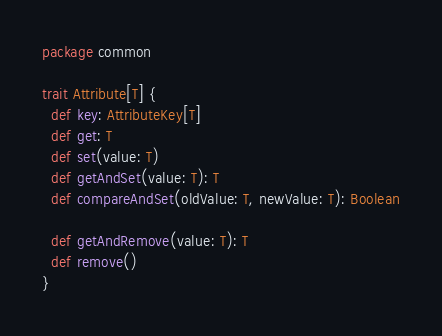Convert code to text. <code><loc_0><loc_0><loc_500><loc_500><_Scala_>package common

trait Attribute[T] {
  def key: AttributeKey[T]
  def get: T
  def set(value: T)
  def getAndSet(value: T): T
  def compareAndSet(oldValue: T, newValue: T): Boolean

  def getAndRemove(value: T): T
  def remove()
}
</code> 